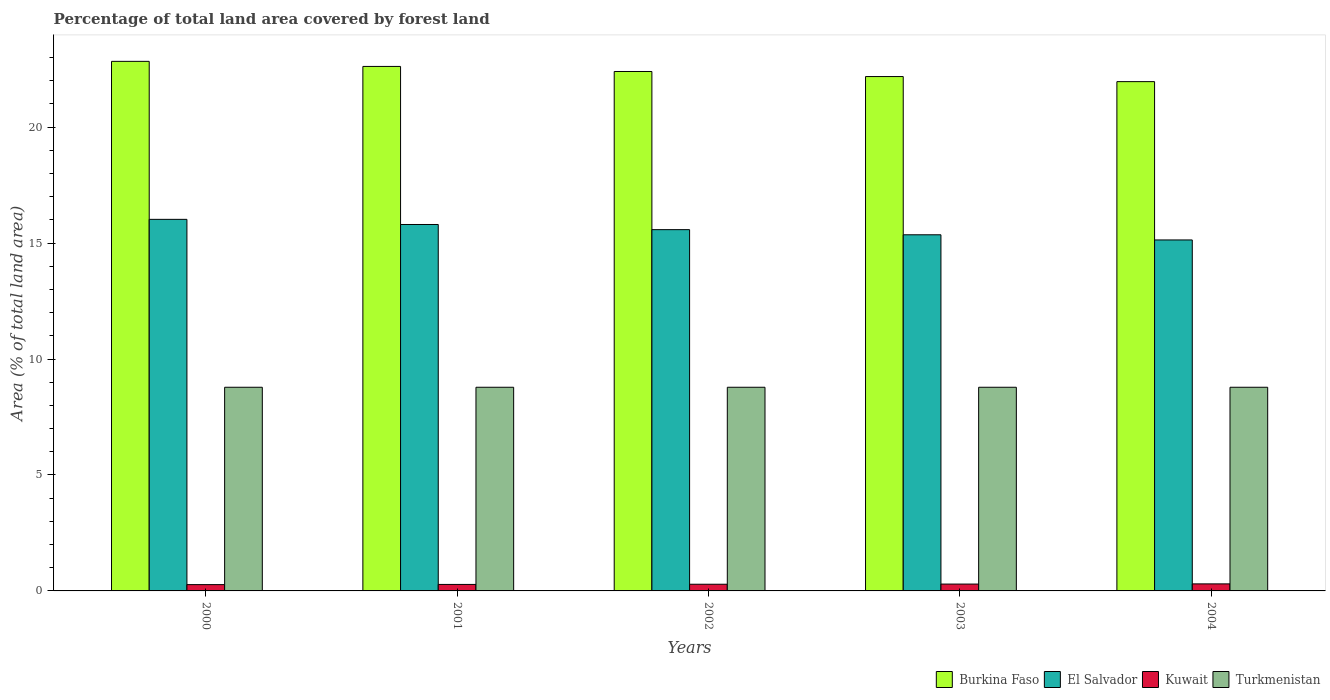How many different coloured bars are there?
Offer a very short reply. 4. How many groups of bars are there?
Your response must be concise. 5. Are the number of bars per tick equal to the number of legend labels?
Provide a short and direct response. Yes. Are the number of bars on each tick of the X-axis equal?
Provide a short and direct response. Yes. How many bars are there on the 2nd tick from the left?
Give a very brief answer. 4. What is the label of the 1st group of bars from the left?
Provide a succinct answer. 2000. What is the percentage of forest land in El Salvador in 2001?
Provide a short and direct response. 15.8. Across all years, what is the maximum percentage of forest land in Turkmenistan?
Your response must be concise. 8.78. Across all years, what is the minimum percentage of forest land in Turkmenistan?
Your answer should be compact. 8.78. In which year was the percentage of forest land in Kuwait minimum?
Keep it short and to the point. 2000. What is the total percentage of forest land in Burkina Faso in the graph?
Your answer should be compact. 112. What is the difference between the percentage of forest land in El Salvador in 2001 and that in 2002?
Offer a very short reply. 0.22. What is the difference between the percentage of forest land in Turkmenistan in 2001 and the percentage of forest land in Kuwait in 2004?
Your response must be concise. 8.48. What is the average percentage of forest land in El Salvador per year?
Provide a succinct answer. 15.58. In the year 2001, what is the difference between the percentage of forest land in Kuwait and percentage of forest land in Burkina Faso?
Offer a terse response. -22.34. What is the ratio of the percentage of forest land in Kuwait in 2000 to that in 2003?
Provide a succinct answer. 0.92. Is the percentage of forest land in Turkmenistan in 2001 less than that in 2004?
Your answer should be compact. No. Is the difference between the percentage of forest land in Kuwait in 2000 and 2002 greater than the difference between the percentage of forest land in Burkina Faso in 2000 and 2002?
Provide a short and direct response. No. What is the difference between the highest and the second highest percentage of forest land in El Salvador?
Your response must be concise. 0.22. What is the difference between the highest and the lowest percentage of forest land in Kuwait?
Make the answer very short. 0.03. Is the sum of the percentage of forest land in Kuwait in 2002 and 2003 greater than the maximum percentage of forest land in El Salvador across all years?
Your response must be concise. No. What does the 2nd bar from the left in 2003 represents?
Your answer should be very brief. El Salvador. What does the 4th bar from the right in 2004 represents?
Your answer should be compact. Burkina Faso. Is it the case that in every year, the sum of the percentage of forest land in Turkmenistan and percentage of forest land in Burkina Faso is greater than the percentage of forest land in Kuwait?
Give a very brief answer. Yes. How many bars are there?
Provide a short and direct response. 20. Are all the bars in the graph horizontal?
Give a very brief answer. No. How many years are there in the graph?
Offer a terse response. 5. What is the difference between two consecutive major ticks on the Y-axis?
Provide a succinct answer. 5. Are the values on the major ticks of Y-axis written in scientific E-notation?
Your answer should be compact. No. Does the graph contain any zero values?
Your answer should be very brief. No. Does the graph contain grids?
Your answer should be very brief. No. Where does the legend appear in the graph?
Ensure brevity in your answer.  Bottom right. What is the title of the graph?
Your response must be concise. Percentage of total land area covered by forest land. What is the label or title of the Y-axis?
Your answer should be compact. Area (% of total land area). What is the Area (% of total land area) of Burkina Faso in 2000?
Offer a terse response. 22.84. What is the Area (% of total land area) of El Salvador in 2000?
Make the answer very short. 16.02. What is the Area (% of total land area) in Kuwait in 2000?
Give a very brief answer. 0.27. What is the Area (% of total land area) in Turkmenistan in 2000?
Your answer should be very brief. 8.78. What is the Area (% of total land area) in Burkina Faso in 2001?
Ensure brevity in your answer.  22.62. What is the Area (% of total land area) of El Salvador in 2001?
Your response must be concise. 15.8. What is the Area (% of total land area) of Kuwait in 2001?
Ensure brevity in your answer.  0.28. What is the Area (% of total land area) in Turkmenistan in 2001?
Provide a succinct answer. 8.78. What is the Area (% of total land area) in Burkina Faso in 2002?
Offer a terse response. 22.4. What is the Area (% of total land area) of El Salvador in 2002?
Your response must be concise. 15.58. What is the Area (% of total land area) of Kuwait in 2002?
Keep it short and to the point. 0.29. What is the Area (% of total land area) in Turkmenistan in 2002?
Your answer should be compact. 8.78. What is the Area (% of total land area) of Burkina Faso in 2003?
Your response must be concise. 22.18. What is the Area (% of total land area) in El Salvador in 2003?
Keep it short and to the point. 15.36. What is the Area (% of total land area) in Kuwait in 2003?
Provide a short and direct response. 0.3. What is the Area (% of total land area) of Turkmenistan in 2003?
Offer a terse response. 8.78. What is the Area (% of total land area) of Burkina Faso in 2004?
Make the answer very short. 21.96. What is the Area (% of total land area) of El Salvador in 2004?
Offer a terse response. 15.14. What is the Area (% of total land area) of Kuwait in 2004?
Ensure brevity in your answer.  0.3. What is the Area (% of total land area) of Turkmenistan in 2004?
Keep it short and to the point. 8.78. Across all years, what is the maximum Area (% of total land area) in Burkina Faso?
Your answer should be very brief. 22.84. Across all years, what is the maximum Area (% of total land area) in El Salvador?
Make the answer very short. 16.02. Across all years, what is the maximum Area (% of total land area) of Kuwait?
Make the answer very short. 0.3. Across all years, what is the maximum Area (% of total land area) in Turkmenistan?
Offer a very short reply. 8.78. Across all years, what is the minimum Area (% of total land area) in Burkina Faso?
Offer a terse response. 21.96. Across all years, what is the minimum Area (% of total land area) of El Salvador?
Offer a very short reply. 15.14. Across all years, what is the minimum Area (% of total land area) in Kuwait?
Your response must be concise. 0.27. Across all years, what is the minimum Area (% of total land area) of Turkmenistan?
Give a very brief answer. 8.78. What is the total Area (% of total land area) of Burkina Faso in the graph?
Provide a succinct answer. 112. What is the total Area (% of total land area) of El Salvador in the graph?
Your answer should be compact. 77.9. What is the total Area (% of total land area) of Kuwait in the graph?
Provide a short and direct response. 1.44. What is the total Area (% of total land area) of Turkmenistan in the graph?
Offer a very short reply. 43.91. What is the difference between the Area (% of total land area) in Burkina Faso in 2000 and that in 2001?
Keep it short and to the point. 0.22. What is the difference between the Area (% of total land area) of El Salvador in 2000 and that in 2001?
Make the answer very short. 0.22. What is the difference between the Area (% of total land area) of Kuwait in 2000 and that in 2001?
Provide a succinct answer. -0.01. What is the difference between the Area (% of total land area) in Burkina Faso in 2000 and that in 2002?
Provide a short and direct response. 0.44. What is the difference between the Area (% of total land area) in El Salvador in 2000 and that in 2002?
Offer a very short reply. 0.44. What is the difference between the Area (% of total land area) of Kuwait in 2000 and that in 2002?
Give a very brief answer. -0.02. What is the difference between the Area (% of total land area) in Burkina Faso in 2000 and that in 2003?
Offer a terse response. 0.66. What is the difference between the Area (% of total land area) of El Salvador in 2000 and that in 2003?
Give a very brief answer. 0.67. What is the difference between the Area (% of total land area) of Kuwait in 2000 and that in 2003?
Give a very brief answer. -0.02. What is the difference between the Area (% of total land area) of Burkina Faso in 2000 and that in 2004?
Your response must be concise. 0.87. What is the difference between the Area (% of total land area) of El Salvador in 2000 and that in 2004?
Your answer should be compact. 0.89. What is the difference between the Area (% of total land area) in Kuwait in 2000 and that in 2004?
Provide a short and direct response. -0.03. What is the difference between the Area (% of total land area) in Burkina Faso in 2001 and that in 2002?
Provide a succinct answer. 0.22. What is the difference between the Area (% of total land area) in El Salvador in 2001 and that in 2002?
Provide a succinct answer. 0.22. What is the difference between the Area (% of total land area) in Kuwait in 2001 and that in 2002?
Ensure brevity in your answer.  -0.01. What is the difference between the Area (% of total land area) of Burkina Faso in 2001 and that in 2003?
Your answer should be very brief. 0.44. What is the difference between the Area (% of total land area) in El Salvador in 2001 and that in 2003?
Provide a succinct answer. 0.44. What is the difference between the Area (% of total land area) in Kuwait in 2001 and that in 2003?
Provide a short and direct response. -0.02. What is the difference between the Area (% of total land area) of Burkina Faso in 2001 and that in 2004?
Offer a very short reply. 0.66. What is the difference between the Area (% of total land area) in El Salvador in 2001 and that in 2004?
Give a very brief answer. 0.67. What is the difference between the Area (% of total land area) in Kuwait in 2001 and that in 2004?
Offer a terse response. -0.02. What is the difference between the Area (% of total land area) in Burkina Faso in 2002 and that in 2003?
Offer a very short reply. 0.22. What is the difference between the Area (% of total land area) in El Salvador in 2002 and that in 2003?
Your response must be concise. 0.22. What is the difference between the Area (% of total land area) of Kuwait in 2002 and that in 2003?
Offer a very short reply. -0.01. What is the difference between the Area (% of total land area) of Turkmenistan in 2002 and that in 2003?
Provide a short and direct response. 0. What is the difference between the Area (% of total land area) of Burkina Faso in 2002 and that in 2004?
Offer a very short reply. 0.44. What is the difference between the Area (% of total land area) in El Salvador in 2002 and that in 2004?
Offer a terse response. 0.44. What is the difference between the Area (% of total land area) of Kuwait in 2002 and that in 2004?
Your response must be concise. -0.02. What is the difference between the Area (% of total land area) in Turkmenistan in 2002 and that in 2004?
Keep it short and to the point. 0. What is the difference between the Area (% of total land area) of Burkina Faso in 2003 and that in 2004?
Provide a succinct answer. 0.22. What is the difference between the Area (% of total land area) in El Salvador in 2003 and that in 2004?
Make the answer very short. 0.22. What is the difference between the Area (% of total land area) in Kuwait in 2003 and that in 2004?
Your response must be concise. -0.01. What is the difference between the Area (% of total land area) of Burkina Faso in 2000 and the Area (% of total land area) of El Salvador in 2001?
Provide a succinct answer. 7.04. What is the difference between the Area (% of total land area) of Burkina Faso in 2000 and the Area (% of total land area) of Kuwait in 2001?
Provide a short and direct response. 22.56. What is the difference between the Area (% of total land area) of Burkina Faso in 2000 and the Area (% of total land area) of Turkmenistan in 2001?
Keep it short and to the point. 14.05. What is the difference between the Area (% of total land area) in El Salvador in 2000 and the Area (% of total land area) in Kuwait in 2001?
Offer a very short reply. 15.74. What is the difference between the Area (% of total land area) of El Salvador in 2000 and the Area (% of total land area) of Turkmenistan in 2001?
Your answer should be very brief. 7.24. What is the difference between the Area (% of total land area) of Kuwait in 2000 and the Area (% of total land area) of Turkmenistan in 2001?
Keep it short and to the point. -8.51. What is the difference between the Area (% of total land area) of Burkina Faso in 2000 and the Area (% of total land area) of El Salvador in 2002?
Offer a very short reply. 7.26. What is the difference between the Area (% of total land area) of Burkina Faso in 2000 and the Area (% of total land area) of Kuwait in 2002?
Keep it short and to the point. 22.55. What is the difference between the Area (% of total land area) of Burkina Faso in 2000 and the Area (% of total land area) of Turkmenistan in 2002?
Ensure brevity in your answer.  14.05. What is the difference between the Area (% of total land area) of El Salvador in 2000 and the Area (% of total land area) of Kuwait in 2002?
Provide a short and direct response. 15.74. What is the difference between the Area (% of total land area) in El Salvador in 2000 and the Area (% of total land area) in Turkmenistan in 2002?
Your answer should be compact. 7.24. What is the difference between the Area (% of total land area) in Kuwait in 2000 and the Area (% of total land area) in Turkmenistan in 2002?
Offer a terse response. -8.51. What is the difference between the Area (% of total land area) in Burkina Faso in 2000 and the Area (% of total land area) in El Salvador in 2003?
Offer a terse response. 7.48. What is the difference between the Area (% of total land area) of Burkina Faso in 2000 and the Area (% of total land area) of Kuwait in 2003?
Keep it short and to the point. 22.54. What is the difference between the Area (% of total land area) in Burkina Faso in 2000 and the Area (% of total land area) in Turkmenistan in 2003?
Provide a succinct answer. 14.05. What is the difference between the Area (% of total land area) of El Salvador in 2000 and the Area (% of total land area) of Kuwait in 2003?
Your response must be concise. 15.73. What is the difference between the Area (% of total land area) of El Salvador in 2000 and the Area (% of total land area) of Turkmenistan in 2003?
Your response must be concise. 7.24. What is the difference between the Area (% of total land area) of Kuwait in 2000 and the Area (% of total land area) of Turkmenistan in 2003?
Provide a succinct answer. -8.51. What is the difference between the Area (% of total land area) in Burkina Faso in 2000 and the Area (% of total land area) in El Salvador in 2004?
Your answer should be compact. 7.7. What is the difference between the Area (% of total land area) in Burkina Faso in 2000 and the Area (% of total land area) in Kuwait in 2004?
Your response must be concise. 22.53. What is the difference between the Area (% of total land area) of Burkina Faso in 2000 and the Area (% of total land area) of Turkmenistan in 2004?
Provide a short and direct response. 14.05. What is the difference between the Area (% of total land area) of El Salvador in 2000 and the Area (% of total land area) of Kuwait in 2004?
Make the answer very short. 15.72. What is the difference between the Area (% of total land area) of El Salvador in 2000 and the Area (% of total land area) of Turkmenistan in 2004?
Keep it short and to the point. 7.24. What is the difference between the Area (% of total land area) in Kuwait in 2000 and the Area (% of total land area) in Turkmenistan in 2004?
Your answer should be very brief. -8.51. What is the difference between the Area (% of total land area) of Burkina Faso in 2001 and the Area (% of total land area) of El Salvador in 2002?
Give a very brief answer. 7.04. What is the difference between the Area (% of total land area) of Burkina Faso in 2001 and the Area (% of total land area) of Kuwait in 2002?
Make the answer very short. 22.33. What is the difference between the Area (% of total land area) in Burkina Faso in 2001 and the Area (% of total land area) in Turkmenistan in 2002?
Your answer should be compact. 13.84. What is the difference between the Area (% of total land area) of El Salvador in 2001 and the Area (% of total land area) of Kuwait in 2002?
Offer a very short reply. 15.51. What is the difference between the Area (% of total land area) in El Salvador in 2001 and the Area (% of total land area) in Turkmenistan in 2002?
Your response must be concise. 7.02. What is the difference between the Area (% of total land area) in Kuwait in 2001 and the Area (% of total land area) in Turkmenistan in 2002?
Make the answer very short. -8.5. What is the difference between the Area (% of total land area) of Burkina Faso in 2001 and the Area (% of total land area) of El Salvador in 2003?
Your response must be concise. 7.26. What is the difference between the Area (% of total land area) in Burkina Faso in 2001 and the Area (% of total land area) in Kuwait in 2003?
Your answer should be very brief. 22.32. What is the difference between the Area (% of total land area) in Burkina Faso in 2001 and the Area (% of total land area) in Turkmenistan in 2003?
Keep it short and to the point. 13.84. What is the difference between the Area (% of total land area) of El Salvador in 2001 and the Area (% of total land area) of Kuwait in 2003?
Offer a terse response. 15.51. What is the difference between the Area (% of total land area) in El Salvador in 2001 and the Area (% of total land area) in Turkmenistan in 2003?
Provide a short and direct response. 7.02. What is the difference between the Area (% of total land area) of Kuwait in 2001 and the Area (% of total land area) of Turkmenistan in 2003?
Your answer should be very brief. -8.5. What is the difference between the Area (% of total land area) of Burkina Faso in 2001 and the Area (% of total land area) of El Salvador in 2004?
Keep it short and to the point. 7.48. What is the difference between the Area (% of total land area) in Burkina Faso in 2001 and the Area (% of total land area) in Kuwait in 2004?
Offer a very short reply. 22.31. What is the difference between the Area (% of total land area) in Burkina Faso in 2001 and the Area (% of total land area) in Turkmenistan in 2004?
Provide a short and direct response. 13.84. What is the difference between the Area (% of total land area) in El Salvador in 2001 and the Area (% of total land area) in Kuwait in 2004?
Ensure brevity in your answer.  15.5. What is the difference between the Area (% of total land area) in El Salvador in 2001 and the Area (% of total land area) in Turkmenistan in 2004?
Offer a terse response. 7.02. What is the difference between the Area (% of total land area) in Kuwait in 2001 and the Area (% of total land area) in Turkmenistan in 2004?
Your response must be concise. -8.5. What is the difference between the Area (% of total land area) in Burkina Faso in 2002 and the Area (% of total land area) in El Salvador in 2003?
Ensure brevity in your answer.  7.04. What is the difference between the Area (% of total land area) in Burkina Faso in 2002 and the Area (% of total land area) in Kuwait in 2003?
Offer a terse response. 22.1. What is the difference between the Area (% of total land area) of Burkina Faso in 2002 and the Area (% of total land area) of Turkmenistan in 2003?
Ensure brevity in your answer.  13.62. What is the difference between the Area (% of total land area) in El Salvador in 2002 and the Area (% of total land area) in Kuwait in 2003?
Provide a succinct answer. 15.28. What is the difference between the Area (% of total land area) in El Salvador in 2002 and the Area (% of total land area) in Turkmenistan in 2003?
Offer a very short reply. 6.8. What is the difference between the Area (% of total land area) in Kuwait in 2002 and the Area (% of total land area) in Turkmenistan in 2003?
Provide a short and direct response. -8.49. What is the difference between the Area (% of total land area) in Burkina Faso in 2002 and the Area (% of total land area) in El Salvador in 2004?
Provide a short and direct response. 7.26. What is the difference between the Area (% of total land area) of Burkina Faso in 2002 and the Area (% of total land area) of Kuwait in 2004?
Your answer should be very brief. 22.1. What is the difference between the Area (% of total land area) of Burkina Faso in 2002 and the Area (% of total land area) of Turkmenistan in 2004?
Offer a terse response. 13.62. What is the difference between the Area (% of total land area) of El Salvador in 2002 and the Area (% of total land area) of Kuwait in 2004?
Offer a very short reply. 15.28. What is the difference between the Area (% of total land area) of El Salvador in 2002 and the Area (% of total land area) of Turkmenistan in 2004?
Keep it short and to the point. 6.8. What is the difference between the Area (% of total land area) of Kuwait in 2002 and the Area (% of total land area) of Turkmenistan in 2004?
Your answer should be compact. -8.49. What is the difference between the Area (% of total land area) of Burkina Faso in 2003 and the Area (% of total land area) of El Salvador in 2004?
Ensure brevity in your answer.  7.05. What is the difference between the Area (% of total land area) of Burkina Faso in 2003 and the Area (% of total land area) of Kuwait in 2004?
Make the answer very short. 21.88. What is the difference between the Area (% of total land area) in Burkina Faso in 2003 and the Area (% of total land area) in Turkmenistan in 2004?
Offer a very short reply. 13.4. What is the difference between the Area (% of total land area) of El Salvador in 2003 and the Area (% of total land area) of Kuwait in 2004?
Keep it short and to the point. 15.05. What is the difference between the Area (% of total land area) of El Salvador in 2003 and the Area (% of total land area) of Turkmenistan in 2004?
Ensure brevity in your answer.  6.58. What is the difference between the Area (% of total land area) of Kuwait in 2003 and the Area (% of total land area) of Turkmenistan in 2004?
Your answer should be very brief. -8.49. What is the average Area (% of total land area) in Burkina Faso per year?
Provide a succinct answer. 22.4. What is the average Area (% of total land area) in El Salvador per year?
Ensure brevity in your answer.  15.58. What is the average Area (% of total land area) in Kuwait per year?
Your answer should be very brief. 0.29. What is the average Area (% of total land area) in Turkmenistan per year?
Your answer should be compact. 8.78. In the year 2000, what is the difference between the Area (% of total land area) of Burkina Faso and Area (% of total land area) of El Salvador?
Provide a succinct answer. 6.81. In the year 2000, what is the difference between the Area (% of total land area) in Burkina Faso and Area (% of total land area) in Kuwait?
Give a very brief answer. 22.56. In the year 2000, what is the difference between the Area (% of total land area) in Burkina Faso and Area (% of total land area) in Turkmenistan?
Provide a short and direct response. 14.05. In the year 2000, what is the difference between the Area (% of total land area) in El Salvador and Area (% of total land area) in Kuwait?
Your answer should be compact. 15.75. In the year 2000, what is the difference between the Area (% of total land area) in El Salvador and Area (% of total land area) in Turkmenistan?
Offer a terse response. 7.24. In the year 2000, what is the difference between the Area (% of total land area) of Kuwait and Area (% of total land area) of Turkmenistan?
Offer a very short reply. -8.51. In the year 2001, what is the difference between the Area (% of total land area) of Burkina Faso and Area (% of total land area) of El Salvador?
Offer a very short reply. 6.82. In the year 2001, what is the difference between the Area (% of total land area) in Burkina Faso and Area (% of total land area) in Kuwait?
Provide a short and direct response. 22.34. In the year 2001, what is the difference between the Area (% of total land area) of Burkina Faso and Area (% of total land area) of Turkmenistan?
Your response must be concise. 13.84. In the year 2001, what is the difference between the Area (% of total land area) of El Salvador and Area (% of total land area) of Kuwait?
Keep it short and to the point. 15.52. In the year 2001, what is the difference between the Area (% of total land area) in El Salvador and Area (% of total land area) in Turkmenistan?
Give a very brief answer. 7.02. In the year 2001, what is the difference between the Area (% of total land area) in Kuwait and Area (% of total land area) in Turkmenistan?
Provide a short and direct response. -8.5. In the year 2002, what is the difference between the Area (% of total land area) in Burkina Faso and Area (% of total land area) in El Salvador?
Your answer should be very brief. 6.82. In the year 2002, what is the difference between the Area (% of total land area) in Burkina Faso and Area (% of total land area) in Kuwait?
Your answer should be very brief. 22.11. In the year 2002, what is the difference between the Area (% of total land area) of Burkina Faso and Area (% of total land area) of Turkmenistan?
Give a very brief answer. 13.62. In the year 2002, what is the difference between the Area (% of total land area) in El Salvador and Area (% of total land area) in Kuwait?
Make the answer very short. 15.29. In the year 2002, what is the difference between the Area (% of total land area) in El Salvador and Area (% of total land area) in Turkmenistan?
Give a very brief answer. 6.8. In the year 2002, what is the difference between the Area (% of total land area) in Kuwait and Area (% of total land area) in Turkmenistan?
Provide a short and direct response. -8.49. In the year 2003, what is the difference between the Area (% of total land area) in Burkina Faso and Area (% of total land area) in El Salvador?
Provide a succinct answer. 6.82. In the year 2003, what is the difference between the Area (% of total land area) in Burkina Faso and Area (% of total land area) in Kuwait?
Ensure brevity in your answer.  21.88. In the year 2003, what is the difference between the Area (% of total land area) of Burkina Faso and Area (% of total land area) of Turkmenistan?
Provide a short and direct response. 13.4. In the year 2003, what is the difference between the Area (% of total land area) in El Salvador and Area (% of total land area) in Kuwait?
Provide a short and direct response. 15.06. In the year 2003, what is the difference between the Area (% of total land area) in El Salvador and Area (% of total land area) in Turkmenistan?
Provide a succinct answer. 6.58. In the year 2003, what is the difference between the Area (% of total land area) of Kuwait and Area (% of total land area) of Turkmenistan?
Provide a succinct answer. -8.49. In the year 2004, what is the difference between the Area (% of total land area) of Burkina Faso and Area (% of total land area) of El Salvador?
Provide a succinct answer. 6.83. In the year 2004, what is the difference between the Area (% of total land area) in Burkina Faso and Area (% of total land area) in Kuwait?
Provide a succinct answer. 21.66. In the year 2004, what is the difference between the Area (% of total land area) of Burkina Faso and Area (% of total land area) of Turkmenistan?
Offer a very short reply. 13.18. In the year 2004, what is the difference between the Area (% of total land area) of El Salvador and Area (% of total land area) of Kuwait?
Offer a terse response. 14.83. In the year 2004, what is the difference between the Area (% of total land area) of El Salvador and Area (% of total land area) of Turkmenistan?
Make the answer very short. 6.35. In the year 2004, what is the difference between the Area (% of total land area) in Kuwait and Area (% of total land area) in Turkmenistan?
Offer a very short reply. -8.48. What is the ratio of the Area (% of total land area) in Burkina Faso in 2000 to that in 2001?
Your answer should be compact. 1.01. What is the ratio of the Area (% of total land area) of El Salvador in 2000 to that in 2001?
Make the answer very short. 1.01. What is the ratio of the Area (% of total land area) of Kuwait in 2000 to that in 2001?
Give a very brief answer. 0.97. What is the ratio of the Area (% of total land area) of Turkmenistan in 2000 to that in 2001?
Your response must be concise. 1. What is the ratio of the Area (% of total land area) in Burkina Faso in 2000 to that in 2002?
Provide a short and direct response. 1.02. What is the ratio of the Area (% of total land area) in El Salvador in 2000 to that in 2002?
Make the answer very short. 1.03. What is the ratio of the Area (% of total land area) in Kuwait in 2000 to that in 2002?
Give a very brief answer. 0.95. What is the ratio of the Area (% of total land area) in Burkina Faso in 2000 to that in 2003?
Provide a succinct answer. 1.03. What is the ratio of the Area (% of total land area) in El Salvador in 2000 to that in 2003?
Offer a terse response. 1.04. What is the ratio of the Area (% of total land area) in Kuwait in 2000 to that in 2003?
Make the answer very short. 0.92. What is the ratio of the Area (% of total land area) of Burkina Faso in 2000 to that in 2004?
Make the answer very short. 1.04. What is the ratio of the Area (% of total land area) of El Salvador in 2000 to that in 2004?
Offer a terse response. 1.06. What is the ratio of the Area (% of total land area) of Kuwait in 2000 to that in 2004?
Offer a terse response. 0.9. What is the ratio of the Area (% of total land area) in Burkina Faso in 2001 to that in 2002?
Your answer should be compact. 1.01. What is the ratio of the Area (% of total land area) in El Salvador in 2001 to that in 2002?
Ensure brevity in your answer.  1.01. What is the ratio of the Area (% of total land area) in Kuwait in 2001 to that in 2002?
Your answer should be very brief. 0.97. What is the ratio of the Area (% of total land area) of Burkina Faso in 2001 to that in 2003?
Your answer should be very brief. 1.02. What is the ratio of the Area (% of total land area) in El Salvador in 2001 to that in 2003?
Offer a very short reply. 1.03. What is the ratio of the Area (% of total land area) of Kuwait in 2001 to that in 2003?
Offer a very short reply. 0.95. What is the ratio of the Area (% of total land area) in Turkmenistan in 2001 to that in 2003?
Your answer should be very brief. 1. What is the ratio of the Area (% of total land area) of Burkina Faso in 2001 to that in 2004?
Your answer should be very brief. 1.03. What is the ratio of the Area (% of total land area) of El Salvador in 2001 to that in 2004?
Ensure brevity in your answer.  1.04. What is the ratio of the Area (% of total land area) of Kuwait in 2001 to that in 2004?
Ensure brevity in your answer.  0.92. What is the ratio of the Area (% of total land area) of Turkmenistan in 2001 to that in 2004?
Your answer should be compact. 1. What is the ratio of the Area (% of total land area) of Burkina Faso in 2002 to that in 2003?
Provide a short and direct response. 1.01. What is the ratio of the Area (% of total land area) in El Salvador in 2002 to that in 2003?
Give a very brief answer. 1.01. What is the ratio of the Area (% of total land area) in Kuwait in 2002 to that in 2003?
Your answer should be compact. 0.97. What is the ratio of the Area (% of total land area) in Burkina Faso in 2002 to that in 2004?
Keep it short and to the point. 1.02. What is the ratio of the Area (% of total land area) in El Salvador in 2002 to that in 2004?
Your answer should be very brief. 1.03. What is the ratio of the Area (% of total land area) of Kuwait in 2002 to that in 2004?
Offer a terse response. 0.95. What is the ratio of the Area (% of total land area) of Turkmenistan in 2002 to that in 2004?
Offer a terse response. 1. What is the ratio of the Area (% of total land area) of Burkina Faso in 2003 to that in 2004?
Offer a terse response. 1.01. What is the ratio of the Area (% of total land area) of El Salvador in 2003 to that in 2004?
Offer a very short reply. 1.01. What is the ratio of the Area (% of total land area) in Kuwait in 2003 to that in 2004?
Your answer should be compact. 0.97. What is the difference between the highest and the second highest Area (% of total land area) in Burkina Faso?
Offer a terse response. 0.22. What is the difference between the highest and the second highest Area (% of total land area) in El Salvador?
Your answer should be compact. 0.22. What is the difference between the highest and the second highest Area (% of total land area) in Kuwait?
Provide a short and direct response. 0.01. What is the difference between the highest and the second highest Area (% of total land area) in Turkmenistan?
Make the answer very short. 0. What is the difference between the highest and the lowest Area (% of total land area) of Burkina Faso?
Provide a short and direct response. 0.87. What is the difference between the highest and the lowest Area (% of total land area) in El Salvador?
Your answer should be compact. 0.89. What is the difference between the highest and the lowest Area (% of total land area) of Kuwait?
Make the answer very short. 0.03. 